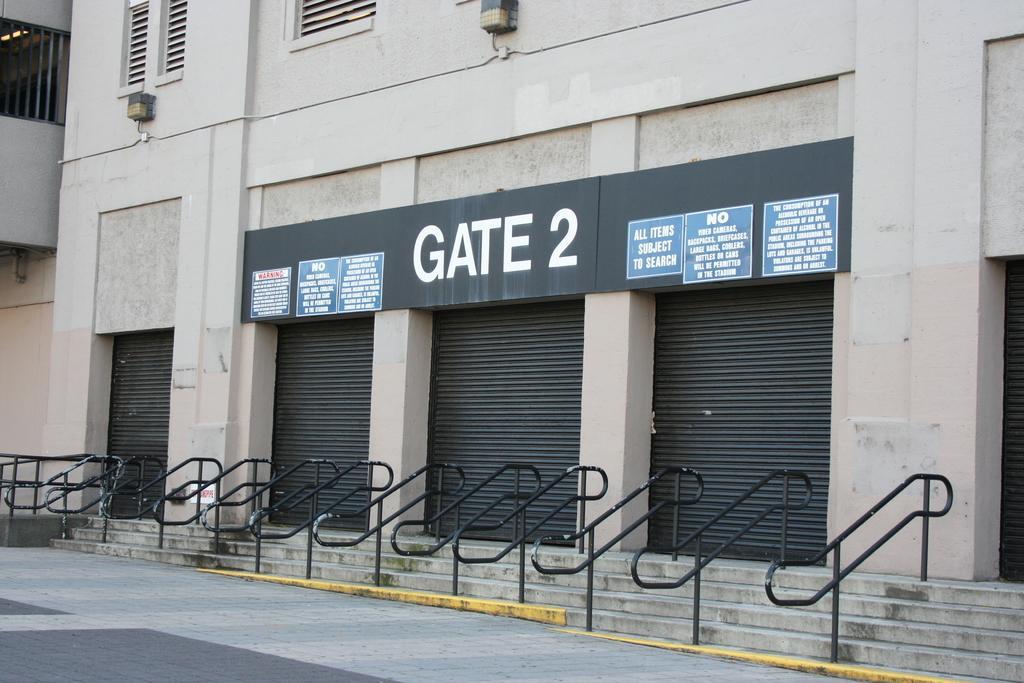Please provide a concise description of this image. In this picture we can observe black color railing in front of this building. We can observe four black color shutters and a board on which there are four papers stuck. The building is in cream color. We can observe a path in front of this building. 